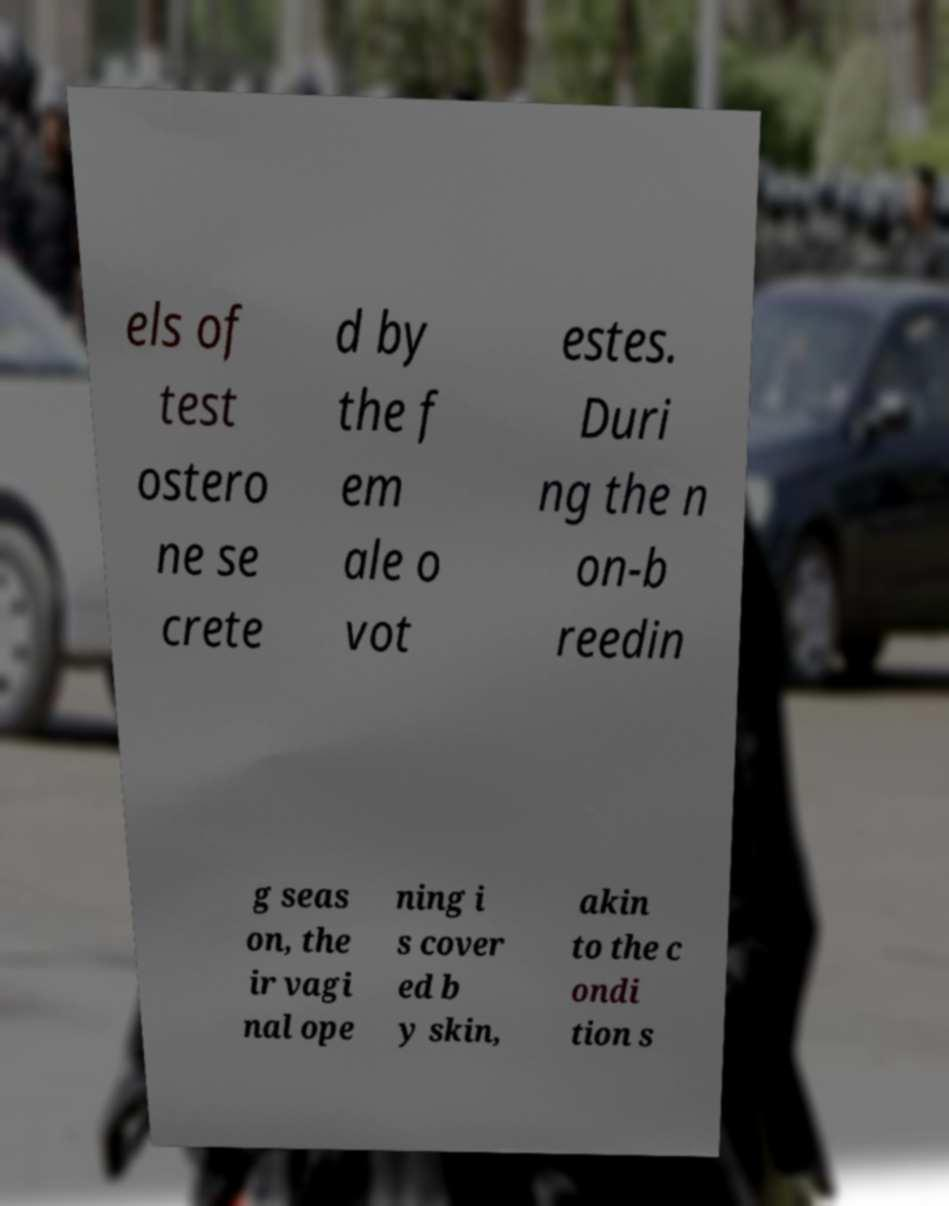Can you accurately transcribe the text from the provided image for me? els of test ostero ne se crete d by the f em ale o vot estes. Duri ng the n on-b reedin g seas on, the ir vagi nal ope ning i s cover ed b y skin, akin to the c ondi tion s 